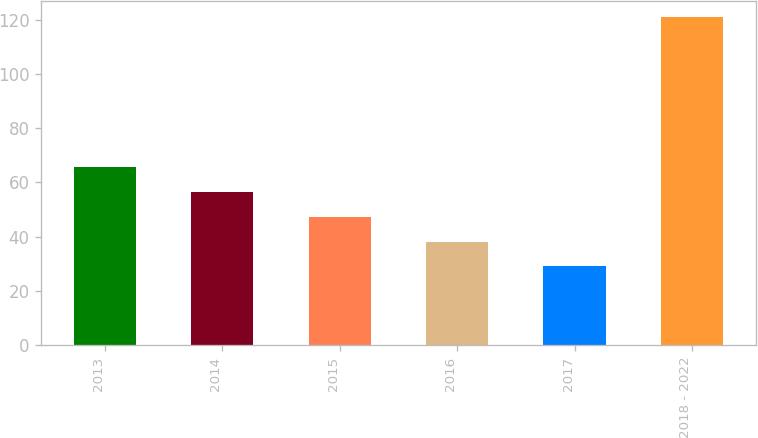Convert chart. <chart><loc_0><loc_0><loc_500><loc_500><bar_chart><fcel>2013<fcel>2014<fcel>2015<fcel>2016<fcel>2017<fcel>2018 - 2022<nl><fcel>65.8<fcel>56.6<fcel>47.4<fcel>38.2<fcel>29<fcel>121<nl></chart> 